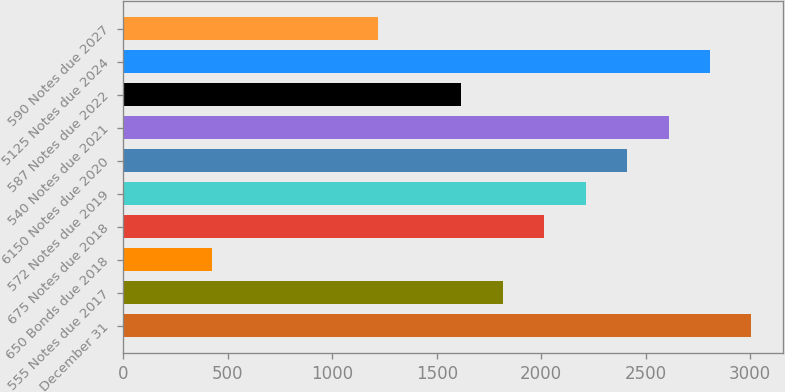Convert chart to OTSL. <chart><loc_0><loc_0><loc_500><loc_500><bar_chart><fcel>December 31<fcel>555 Notes due 2017<fcel>650 Bonds due 2018<fcel>675 Notes due 2018<fcel>572 Notes due 2019<fcel>6150 Notes due 2020<fcel>540 Notes due 2021<fcel>587 Notes due 2022<fcel>5125 Notes due 2024<fcel>590 Notes due 2027<nl><fcel>3006.5<fcel>1815.5<fcel>426<fcel>2014<fcel>2212.5<fcel>2411<fcel>2609.5<fcel>1617<fcel>2808<fcel>1220<nl></chart> 